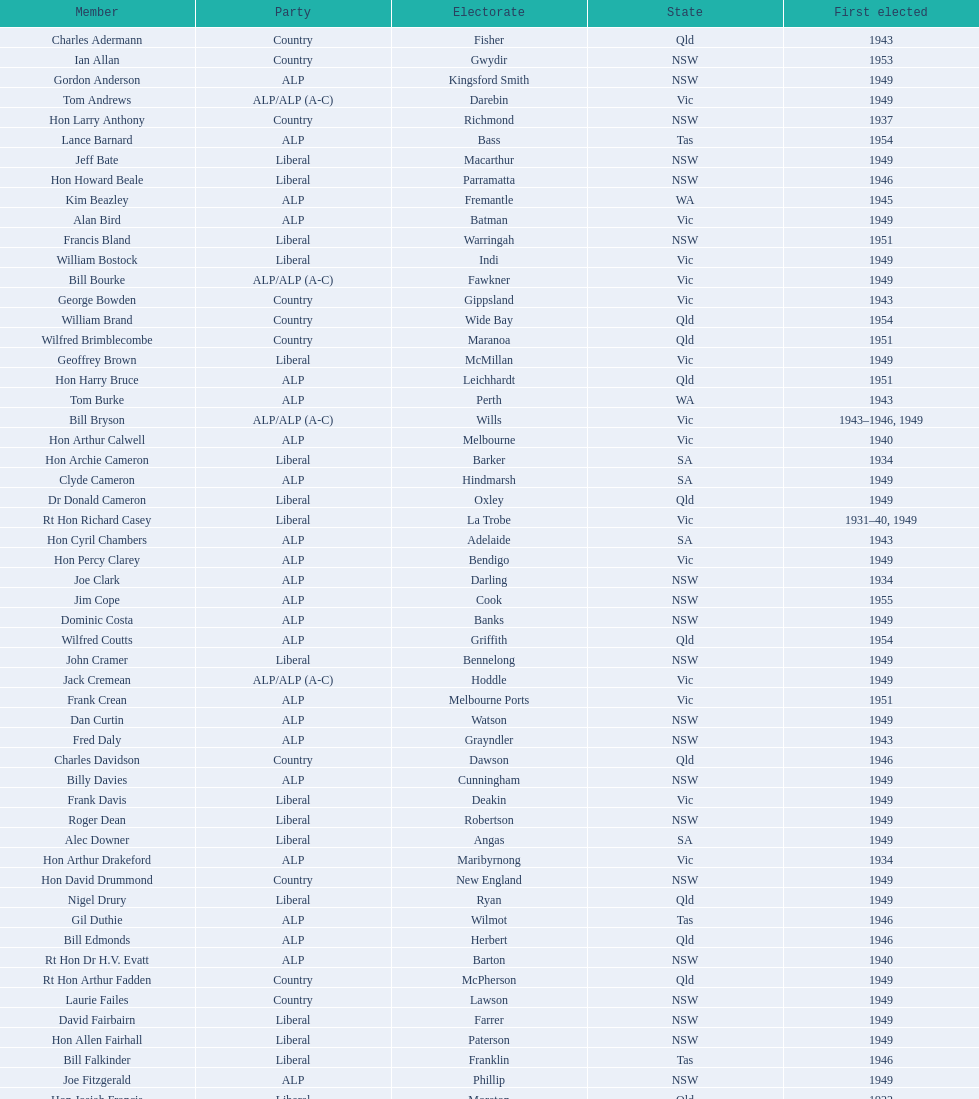Help me parse the entirety of this table. {'header': ['Member', 'Party', 'Electorate', 'State', 'First elected'], 'rows': [['Charles Adermann', 'Country', 'Fisher', 'Qld', '1943'], ['Ian Allan', 'Country', 'Gwydir', 'NSW', '1953'], ['Gordon Anderson', 'ALP', 'Kingsford Smith', 'NSW', '1949'], ['Tom Andrews', 'ALP/ALP (A-C)', 'Darebin', 'Vic', '1949'], ['Hon Larry Anthony', 'Country', 'Richmond', 'NSW', '1937'], ['Lance Barnard', 'ALP', 'Bass', 'Tas', '1954'], ['Jeff Bate', 'Liberal', 'Macarthur', 'NSW', '1949'], ['Hon Howard Beale', 'Liberal', 'Parramatta', 'NSW', '1946'], ['Kim Beazley', 'ALP', 'Fremantle', 'WA', '1945'], ['Alan Bird', 'ALP', 'Batman', 'Vic', '1949'], ['Francis Bland', 'Liberal', 'Warringah', 'NSW', '1951'], ['William Bostock', 'Liberal', 'Indi', 'Vic', '1949'], ['Bill Bourke', 'ALP/ALP (A-C)', 'Fawkner', 'Vic', '1949'], ['George Bowden', 'Country', 'Gippsland', 'Vic', '1943'], ['William Brand', 'Country', 'Wide Bay', 'Qld', '1954'], ['Wilfred Brimblecombe', 'Country', 'Maranoa', 'Qld', '1951'], ['Geoffrey Brown', 'Liberal', 'McMillan', 'Vic', '1949'], ['Hon Harry Bruce', 'ALP', 'Leichhardt', 'Qld', '1951'], ['Tom Burke', 'ALP', 'Perth', 'WA', '1943'], ['Bill Bryson', 'ALP/ALP (A-C)', 'Wills', 'Vic', '1943–1946, 1949'], ['Hon Arthur Calwell', 'ALP', 'Melbourne', 'Vic', '1940'], ['Hon Archie Cameron', 'Liberal', 'Barker', 'SA', '1934'], ['Clyde Cameron', 'ALP', 'Hindmarsh', 'SA', '1949'], ['Dr Donald Cameron', 'Liberal', 'Oxley', 'Qld', '1949'], ['Rt Hon Richard Casey', 'Liberal', 'La Trobe', 'Vic', '1931–40, 1949'], ['Hon Cyril Chambers', 'ALP', 'Adelaide', 'SA', '1943'], ['Hon Percy Clarey', 'ALP', 'Bendigo', 'Vic', '1949'], ['Joe Clark', 'ALP', 'Darling', 'NSW', '1934'], ['Jim Cope', 'ALP', 'Cook', 'NSW', '1955'], ['Dominic Costa', 'ALP', 'Banks', 'NSW', '1949'], ['Wilfred Coutts', 'ALP', 'Griffith', 'Qld', '1954'], ['John Cramer', 'Liberal', 'Bennelong', 'NSW', '1949'], ['Jack Cremean', 'ALP/ALP (A-C)', 'Hoddle', 'Vic', '1949'], ['Frank Crean', 'ALP', 'Melbourne Ports', 'Vic', '1951'], ['Dan Curtin', 'ALP', 'Watson', 'NSW', '1949'], ['Fred Daly', 'ALP', 'Grayndler', 'NSW', '1943'], ['Charles Davidson', 'Country', 'Dawson', 'Qld', '1946'], ['Billy Davies', 'ALP', 'Cunningham', 'NSW', '1949'], ['Frank Davis', 'Liberal', 'Deakin', 'Vic', '1949'], ['Roger Dean', 'Liberal', 'Robertson', 'NSW', '1949'], ['Alec Downer', 'Liberal', 'Angas', 'SA', '1949'], ['Hon Arthur Drakeford', 'ALP', 'Maribyrnong', 'Vic', '1934'], ['Hon David Drummond', 'Country', 'New England', 'NSW', '1949'], ['Nigel Drury', 'Liberal', 'Ryan', 'Qld', '1949'], ['Gil Duthie', 'ALP', 'Wilmot', 'Tas', '1946'], ['Bill Edmonds', 'ALP', 'Herbert', 'Qld', '1946'], ['Rt Hon Dr H.V. Evatt', 'ALP', 'Barton', 'NSW', '1940'], ['Rt Hon Arthur Fadden', 'Country', 'McPherson', 'Qld', '1949'], ['Laurie Failes', 'Country', 'Lawson', 'NSW', '1949'], ['David Fairbairn', 'Liberal', 'Farrer', 'NSW', '1949'], ['Hon Allen Fairhall', 'Liberal', 'Paterson', 'NSW', '1949'], ['Bill Falkinder', 'Liberal', 'Franklin', 'Tas', '1946'], ['Joe Fitzgerald', 'ALP', 'Phillip', 'NSW', '1949'], ['Hon Josiah Francis', 'Liberal', 'Moreton', 'Qld', '1922'], ['Allan Fraser', 'ALP', 'Eden-Monaro', 'NSW', '1943'], ['Jim Fraser', 'ALP', 'Australian Capital Territory', 'ACT', '1951'], ['Gordon Freeth', 'Liberal', 'Forrest', 'WA', '1949'], ['Arthur Fuller', 'Country', 'Hume', 'NSW', '1943–49, 1951'], ['Pat Galvin', 'ALP', 'Kingston', 'SA', '1951'], ['Arthur Greenup', 'ALP', 'Dalley', 'NSW', '1953'], ['Charles Griffiths', 'ALP', 'Shortland', 'NSW', '1949'], ['Jo Gullett', 'Liberal', 'Henty', 'Vic', '1946'], ['Len Hamilton', 'Country', 'Canning', 'WA', '1946'], ['Rt Hon Eric Harrison', 'Liberal', 'Wentworth', 'NSW', '1931'], ['Jim Harrison', 'ALP', 'Blaxland', 'NSW', '1949'], ['Hon Paul Hasluck', 'Liberal', 'Curtin', 'WA', '1949'], ['Hon William Haworth', 'Liberal', 'Isaacs', 'Vic', '1949'], ['Leslie Haylen', 'ALP', 'Parkes', 'NSW', '1943'], ['Rt Hon Harold Holt', 'Liberal', 'Higgins', 'Vic', '1935'], ['John Howse', 'Liberal', 'Calare', 'NSW', '1946'], ['Alan Hulme', 'Liberal', 'Petrie', 'Qld', '1949'], ['William Jack', 'Liberal', 'North Sydney', 'NSW', '1949'], ['Rowley James', 'ALP', 'Hunter', 'NSW', '1928'], ['Hon Herbert Johnson', 'ALP', 'Kalgoorlie', 'WA', '1940'], ['Bob Joshua', 'ALP/ALP (A-C)', 'Ballaarat', 'ALP', '1951'], ['Percy Joske', 'Liberal', 'Balaclava', 'Vic', '1951'], ['Hon Wilfrid Kent Hughes', 'Liberal', 'Chisholm', 'Vic', '1949'], ['Stan Keon', 'ALP/ALP (A-C)', 'Yarra', 'Vic', '1949'], ['William Lawrence', 'Liberal', 'Wimmera', 'Vic', '1949'], ['Hon George Lawson', 'ALP', 'Brisbane', 'Qld', '1931'], ['Nelson Lemmon', 'ALP', 'St George', 'NSW', '1943–49, 1954'], ['Hugh Leslie', 'Liberal', 'Moore', 'Country', '1949'], ['Robert Lindsay', 'Liberal', 'Flinders', 'Vic', '1954'], ['Tony Luchetti', 'ALP', 'Macquarie', 'NSW', '1951'], ['Aubrey Luck', 'Liberal', 'Darwin', 'Tas', '1951'], ['Philip Lucock', 'Country', 'Lyne', 'NSW', '1953'], ['Dan Mackinnon', 'Liberal', 'Corangamite', 'Vic', '1949–51, 1953'], ['Hon Norman Makin', 'ALP', 'Sturt', 'SA', '1919–46, 1954'], ['Hon Philip McBride', 'Liberal', 'Wakefield', 'SA', '1931–37, 1937–43 (S), 1946'], ['Malcolm McColm', 'Liberal', 'Bowman', 'Qld', '1949'], ['Rt Hon John McEwen', 'Country', 'Murray', 'Vic', '1934'], ['John McLeay', 'Liberal', 'Boothby', 'SA', '1949'], ['Don McLeod', 'Liberal', 'Wannon', 'ALP', '1940–49, 1951'], ['Hon William McMahon', 'Liberal', 'Lowe', 'NSW', '1949'], ['Rt Hon Robert Menzies', 'Liberal', 'Kooyong', 'Vic', '1934'], ['Dan Minogue', 'ALP', 'West Sydney', 'NSW', '1949'], ['Charles Morgan', 'ALP', 'Reid', 'NSW', '1940–46, 1949'], ['Jack Mullens', 'ALP/ALP (A-C)', 'Gellibrand', 'Vic', '1949'], ['Jock Nelson', 'ALP', 'Northern Territory', 'NT', '1949'], ["William O'Connor", 'ALP', 'Martin', 'NSW', '1946'], ['Hubert Opperman', 'Liberal', 'Corio', 'Vic', '1949'], ['Hon Frederick Osborne', 'Liberal', 'Evans', 'NSW', '1949'], ['Rt Hon Sir Earle Page', 'Country', 'Cowper', 'NSW', '1919'], ['Henry Pearce', 'Liberal', 'Capricornia', 'Qld', '1949'], ['Ted Peters', 'ALP', 'Burke', 'Vic', '1949'], ['Hon Reg Pollard', 'ALP', 'Lalor', 'Vic', '1937'], ['Hon Bill Riordan', 'ALP', 'Kennedy', 'Qld', '1936'], ['Hugh Roberton', 'Country', 'Riverina', 'NSW', '1949'], ['Edgar Russell', 'ALP', 'Grey', 'SA', '1943'], ['Tom Sheehan', 'ALP', 'Cook', 'NSW', '1937'], ['Frank Stewart', 'ALP', 'Lang', 'NSW', '1953'], ['Reginald Swartz', 'Liberal', 'Darling Downs', 'Qld', '1949'], ['Albert Thompson', 'ALP', 'Port Adelaide', 'SA', '1946'], ['Frank Timson', 'Liberal', 'Higinbotham', 'Vic', '1949'], ['Hon Athol Townley', 'Liberal', 'Denison', 'Tas', '1949'], ['Winton Turnbull', 'Country', 'Mallee', 'Vic', '1946'], ['Harry Turner', 'Liberal', 'Bradfield', 'NSW', '1952'], ['Hon Eddie Ward', 'ALP', 'East Sydney', 'NSW', '1931, 1932'], ['David Oliver Watkins', 'ALP', 'Newcastle', 'NSW', '1935'], ['Harry Webb', 'ALP', 'Swan', 'WA', '1954'], ['William Wentworth', 'Liberal', 'Mackellar', 'NSW', '1949'], ['Roy Wheeler', 'Liberal', 'Mitchell', 'NSW', '1949'], ['Gough Whitlam', 'ALP', 'Werriwa', 'NSW', '1952'], ['Bruce Wight', 'Liberal', 'Lilley', 'Qld', '1949']]} Which party was elected the least? Country. 